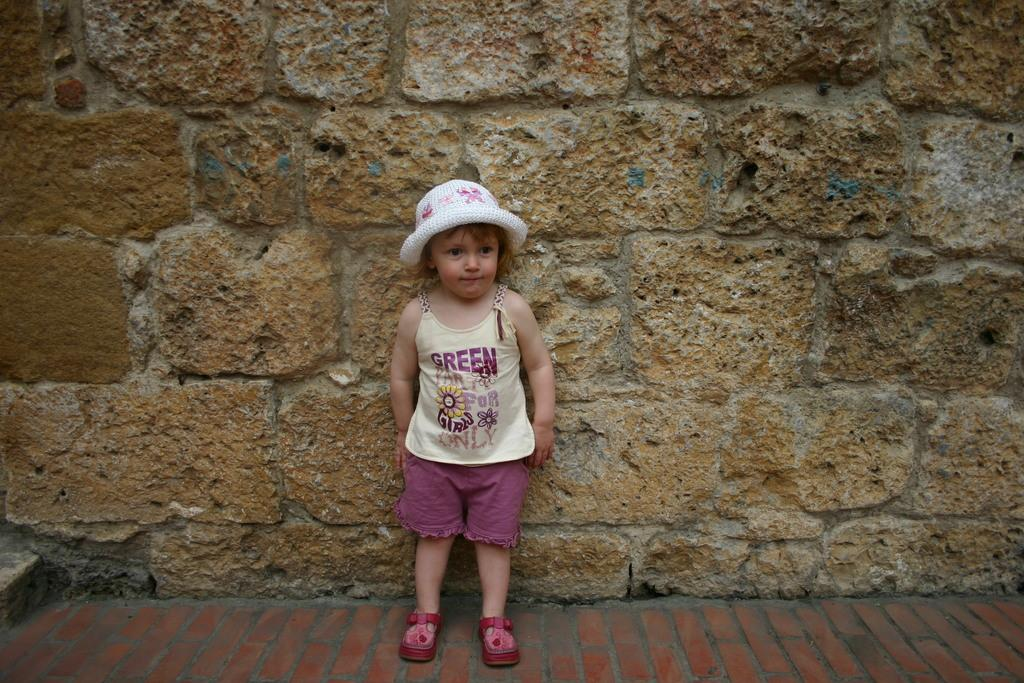Who is in the picture? There is a girl in the picture. What is the girl wearing on her head? The girl is wearing a hat. What type of clothing is the girl wearing on her upper body? The girl is wearing a t-shirt. What type of clothing is the girl wearing on her lower body? The girl is wearing shorts. What type of footwear is the girl wearing? The girl is wearing shoes. Where is the girl standing in relation to the wall? The girl is standing near a wall. What material is the floor made of in the image? The floor in the image is made of bricks. How many sheep can be seen grazing on the bun in the image? There are no sheep or buns present in the image. 